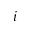<formula> <loc_0><loc_0><loc_500><loc_500>i</formula> 